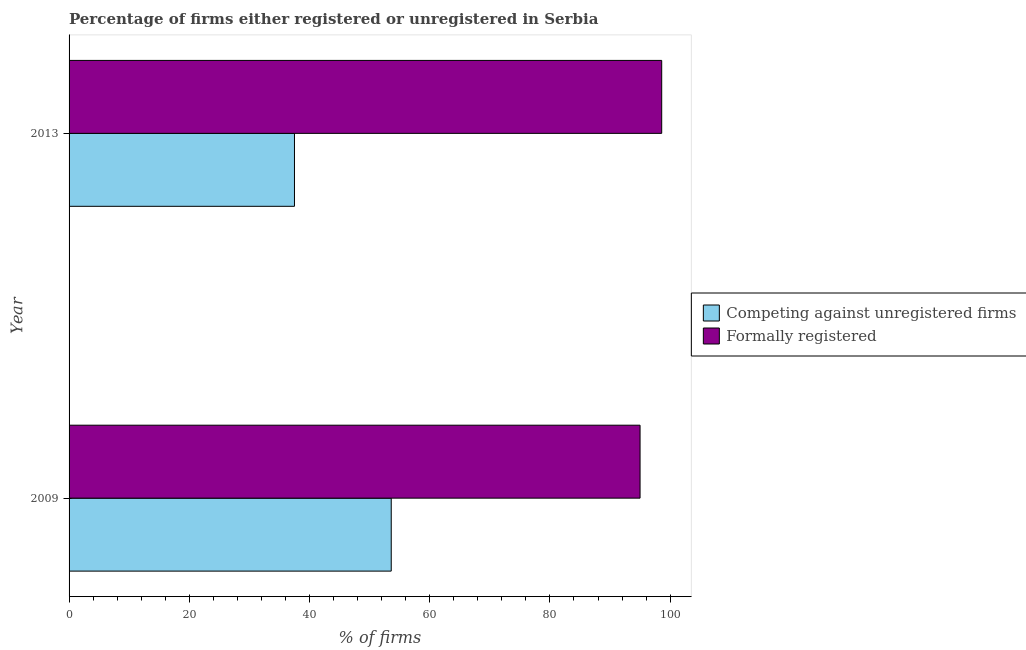Are the number of bars on each tick of the Y-axis equal?
Offer a terse response. Yes. How many bars are there on the 2nd tick from the top?
Your response must be concise. 2. What is the label of the 1st group of bars from the top?
Your answer should be very brief. 2013. In how many cases, is the number of bars for a given year not equal to the number of legend labels?
Keep it short and to the point. 0. What is the percentage of registered firms in 2009?
Your answer should be very brief. 53.6. Across all years, what is the maximum percentage of registered firms?
Ensure brevity in your answer.  53.6. Across all years, what is the minimum percentage of formally registered firms?
Offer a terse response. 95. What is the total percentage of formally registered firms in the graph?
Keep it short and to the point. 193.6. What is the difference between the percentage of formally registered firms in 2009 and that in 2013?
Your response must be concise. -3.6. What is the difference between the percentage of formally registered firms in 2009 and the percentage of registered firms in 2013?
Provide a succinct answer. 57.5. What is the average percentage of registered firms per year?
Keep it short and to the point. 45.55. In the year 2009, what is the difference between the percentage of formally registered firms and percentage of registered firms?
Offer a terse response. 41.4. In how many years, is the percentage of registered firms greater than 76 %?
Your answer should be compact. 0. What is the ratio of the percentage of registered firms in 2009 to that in 2013?
Offer a very short reply. 1.43. Is the percentage of formally registered firms in 2009 less than that in 2013?
Provide a short and direct response. Yes. In how many years, is the percentage of registered firms greater than the average percentage of registered firms taken over all years?
Give a very brief answer. 1. What does the 2nd bar from the top in 2013 represents?
Offer a terse response. Competing against unregistered firms. What does the 2nd bar from the bottom in 2009 represents?
Make the answer very short. Formally registered. How many bars are there?
Your answer should be compact. 4. Are all the bars in the graph horizontal?
Provide a succinct answer. Yes. How many years are there in the graph?
Keep it short and to the point. 2. What is the difference between two consecutive major ticks on the X-axis?
Make the answer very short. 20. Are the values on the major ticks of X-axis written in scientific E-notation?
Your response must be concise. No. Does the graph contain any zero values?
Your answer should be compact. No. Where does the legend appear in the graph?
Your response must be concise. Center right. How many legend labels are there?
Give a very brief answer. 2. How are the legend labels stacked?
Ensure brevity in your answer.  Vertical. What is the title of the graph?
Offer a terse response. Percentage of firms either registered or unregistered in Serbia. What is the label or title of the X-axis?
Offer a terse response. % of firms. What is the label or title of the Y-axis?
Provide a short and direct response. Year. What is the % of firms of Competing against unregistered firms in 2009?
Provide a short and direct response. 53.6. What is the % of firms of Competing against unregistered firms in 2013?
Provide a succinct answer. 37.5. What is the % of firms in Formally registered in 2013?
Offer a terse response. 98.6. Across all years, what is the maximum % of firms in Competing against unregistered firms?
Offer a terse response. 53.6. Across all years, what is the maximum % of firms of Formally registered?
Provide a succinct answer. 98.6. Across all years, what is the minimum % of firms in Competing against unregistered firms?
Make the answer very short. 37.5. What is the total % of firms of Competing against unregistered firms in the graph?
Keep it short and to the point. 91.1. What is the total % of firms of Formally registered in the graph?
Give a very brief answer. 193.6. What is the difference between the % of firms in Competing against unregistered firms in 2009 and that in 2013?
Give a very brief answer. 16.1. What is the difference between the % of firms in Competing against unregistered firms in 2009 and the % of firms in Formally registered in 2013?
Provide a succinct answer. -45. What is the average % of firms of Competing against unregistered firms per year?
Your answer should be very brief. 45.55. What is the average % of firms of Formally registered per year?
Your answer should be very brief. 96.8. In the year 2009, what is the difference between the % of firms of Competing against unregistered firms and % of firms of Formally registered?
Offer a terse response. -41.4. In the year 2013, what is the difference between the % of firms in Competing against unregistered firms and % of firms in Formally registered?
Your answer should be compact. -61.1. What is the ratio of the % of firms of Competing against unregistered firms in 2009 to that in 2013?
Give a very brief answer. 1.43. What is the ratio of the % of firms of Formally registered in 2009 to that in 2013?
Provide a short and direct response. 0.96. What is the difference between the highest and the second highest % of firms of Formally registered?
Your answer should be very brief. 3.6. What is the difference between the highest and the lowest % of firms in Competing against unregistered firms?
Give a very brief answer. 16.1. What is the difference between the highest and the lowest % of firms in Formally registered?
Provide a succinct answer. 3.6. 